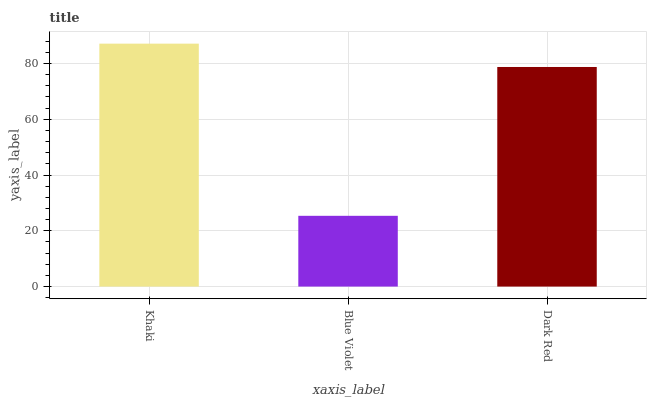Is Dark Red the minimum?
Answer yes or no. No. Is Dark Red the maximum?
Answer yes or no. No. Is Dark Red greater than Blue Violet?
Answer yes or no. Yes. Is Blue Violet less than Dark Red?
Answer yes or no. Yes. Is Blue Violet greater than Dark Red?
Answer yes or no. No. Is Dark Red less than Blue Violet?
Answer yes or no. No. Is Dark Red the high median?
Answer yes or no. Yes. Is Dark Red the low median?
Answer yes or no. Yes. Is Blue Violet the high median?
Answer yes or no. No. Is Blue Violet the low median?
Answer yes or no. No. 